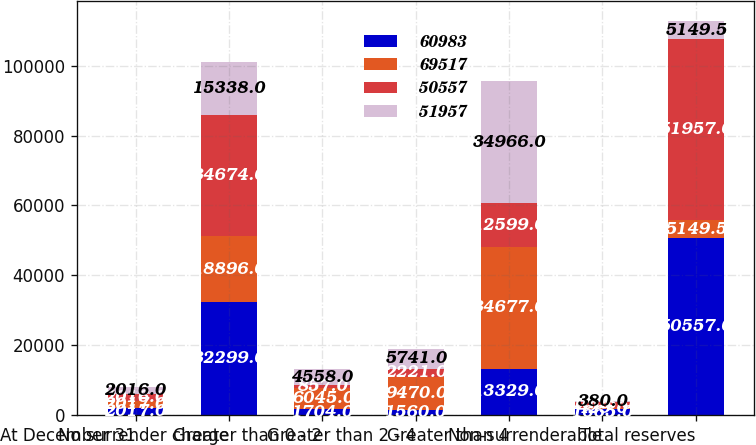<chart> <loc_0><loc_0><loc_500><loc_500><stacked_bar_chart><ecel><fcel>At December 31<fcel>No surrender charge<fcel>Greater than 0 - 2<fcel>Greater than 2 - 4<fcel>Greater than 4<fcel>Non-surrenderable<fcel>Total reserves<nl><fcel>60983<fcel>2017<fcel>32299<fcel>1704<fcel>1560<fcel>13329<fcel>1665<fcel>50557<nl><fcel>69517<fcel>2017<fcel>18896<fcel>6045<fcel>9470<fcel>34677<fcel>429<fcel>5149.5<nl><fcel>50557<fcel>2016<fcel>34674<fcel>857<fcel>2221<fcel>12599<fcel>1606<fcel>51957<nl><fcel>51957<fcel>2016<fcel>15338<fcel>4558<fcel>5741<fcel>34966<fcel>380<fcel>5149.5<nl></chart> 